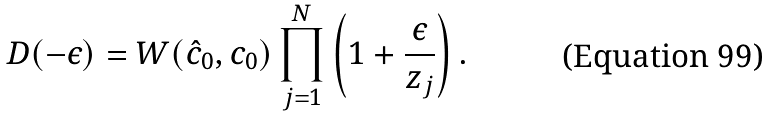Convert formula to latex. <formula><loc_0><loc_0><loc_500><loc_500>D ( - \epsilon ) = W ( \hat { c } _ { 0 } , c _ { 0 } ) \prod _ { j = 1 } ^ { N } \left ( 1 + \frac { \epsilon } { z _ { j } } \right ) .</formula> 